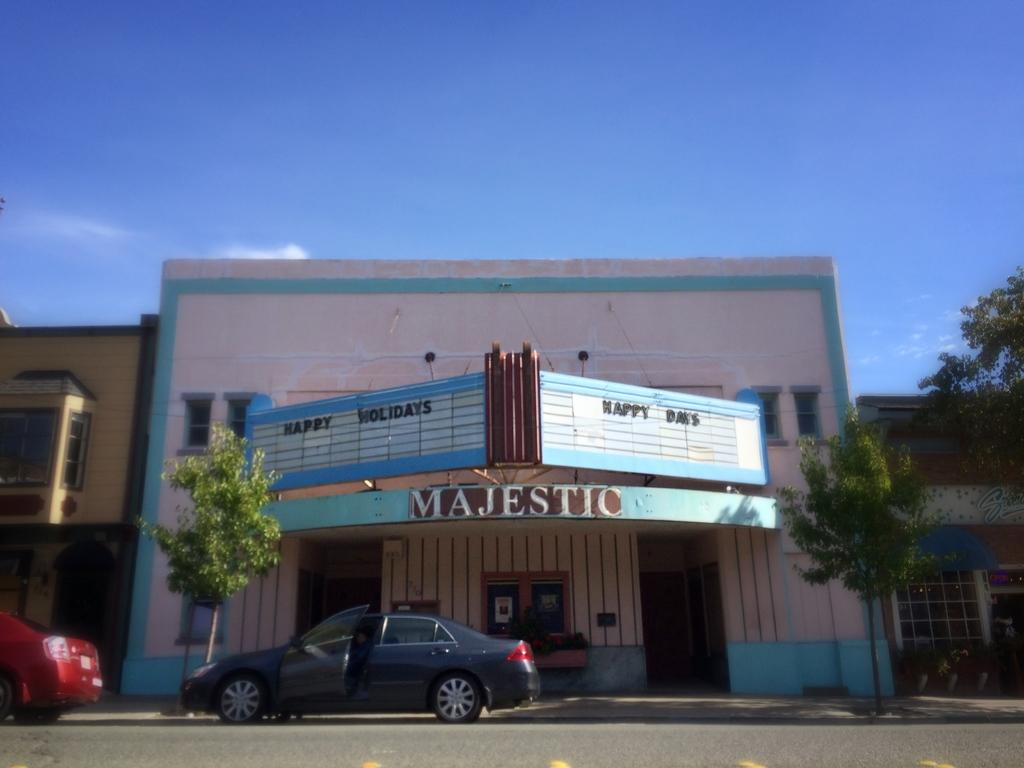What type of structures can be seen in the image? There are buildings in the image. What other natural elements are present in the image? There are trees in the image. What mode of transportation can be seen on the road at the bottom of the image? There are cars on the road at the bottom of the image. What part of the natural environment is visible in the image? The sky is visible in the background of the image. What type of slope can be seen in the image? There is no slope present in the image. What time of day is depicted in the image? The time of day cannot be determined from the image, as there is no indication of the sun's position or any artificial lighting. 